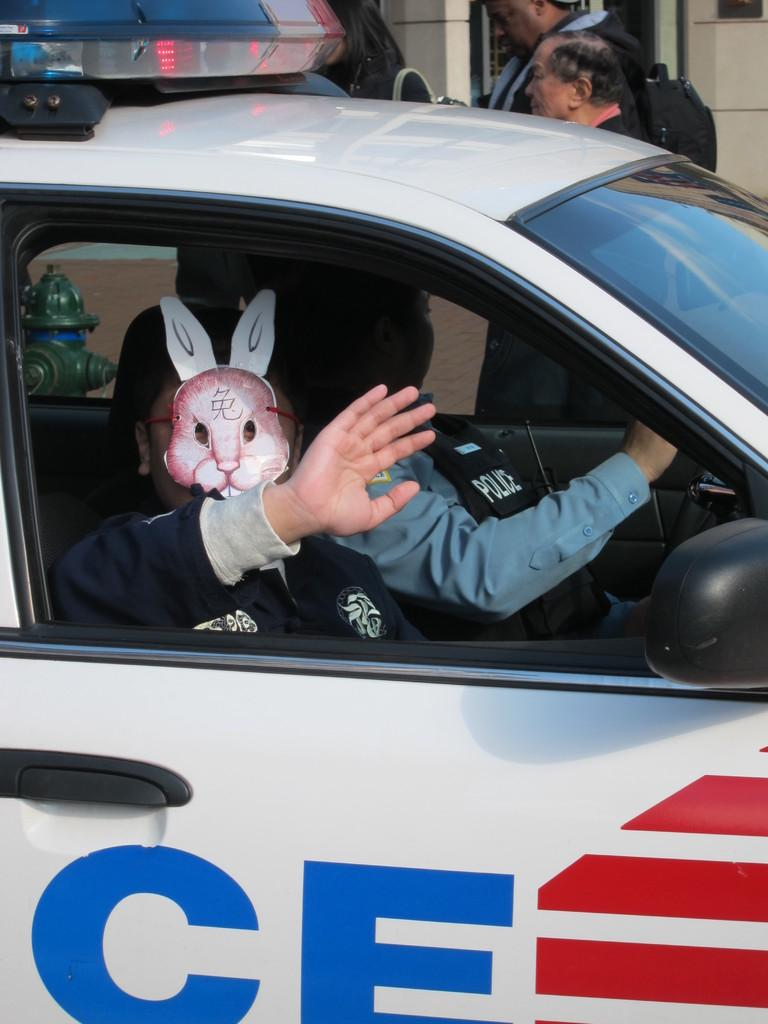What is the main subject of the image? There is a policeman in the image. Can you describe the people in the background of the image? There are persons standing in the background of the image. What type of breakfast is the policeman eating in the image? There is no breakfast present in the image, as it only features a policeman and persons standing in the background. 